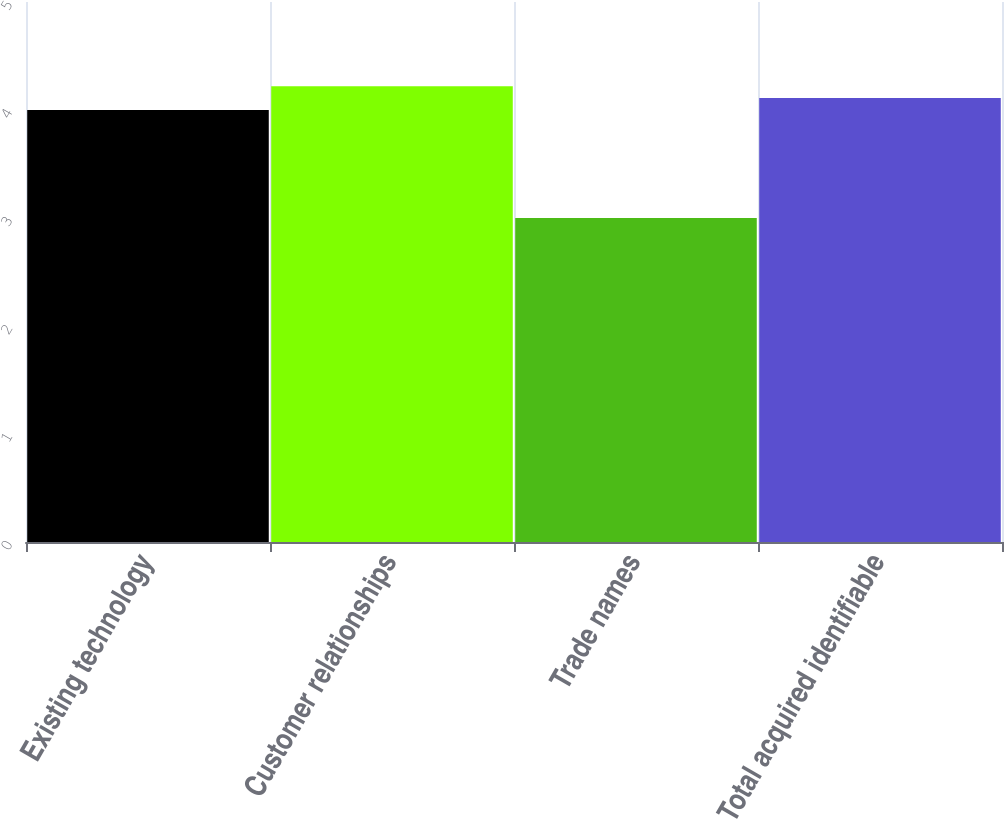Convert chart. <chart><loc_0><loc_0><loc_500><loc_500><bar_chart><fcel>Existing technology<fcel>Customer relationships<fcel>Trade names<fcel>Total acquired identifiable<nl><fcel>4<fcel>4.22<fcel>3<fcel>4.11<nl></chart> 